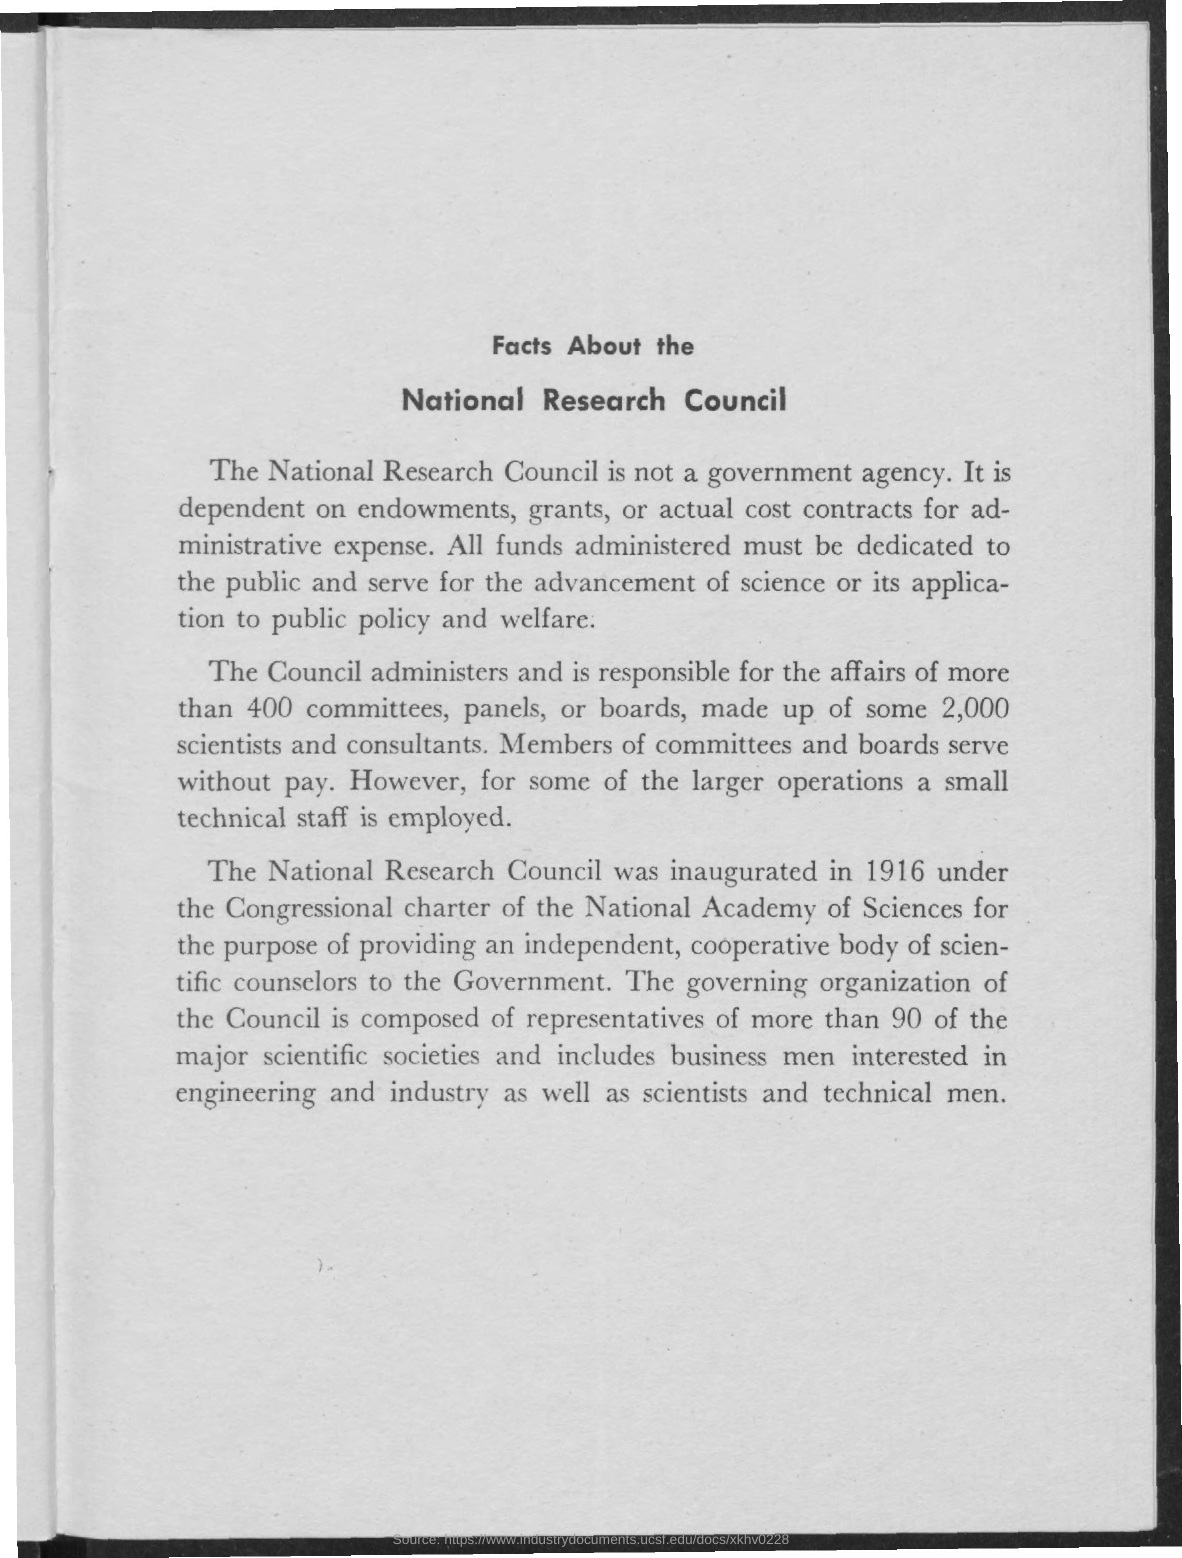When was the national research council inauguarted?
Keep it short and to the point. 1916. 